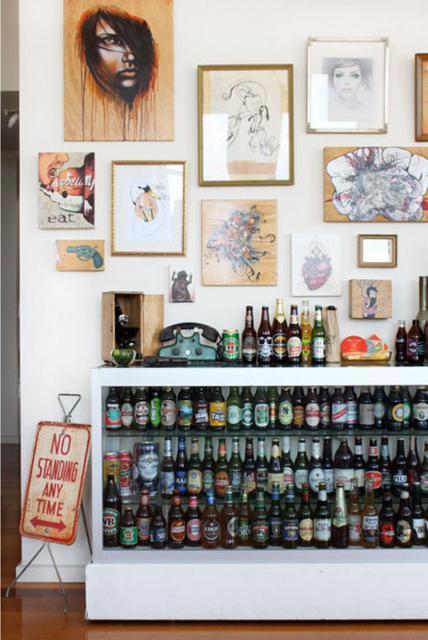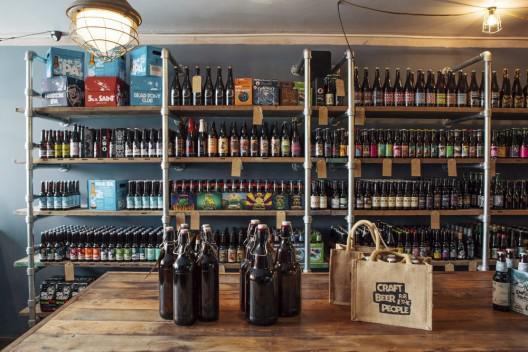The first image is the image on the left, the second image is the image on the right. For the images displayed, is the sentence "The bottles in one of the images do not have caps." factually correct? Answer yes or no. No. 